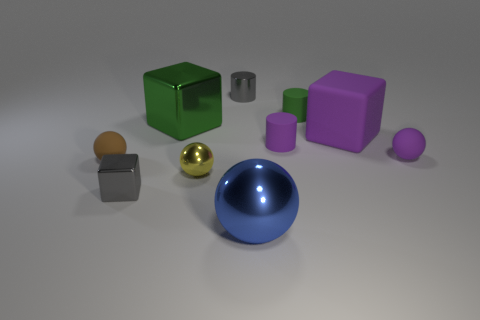Subtract all blocks. How many objects are left? 7 Subtract 2 balls. How many balls are left? 2 Subtract all cyan spheres. Subtract all cyan cubes. How many spheres are left? 4 Subtract all green cylinders. How many gray blocks are left? 1 Subtract all small cubes. Subtract all big cubes. How many objects are left? 7 Add 4 big purple cubes. How many big purple cubes are left? 5 Add 9 big purple rubber cubes. How many big purple rubber cubes exist? 10 Subtract all purple blocks. How many blocks are left? 2 Subtract all green cylinders. How many cylinders are left? 2 Subtract 1 yellow balls. How many objects are left? 9 